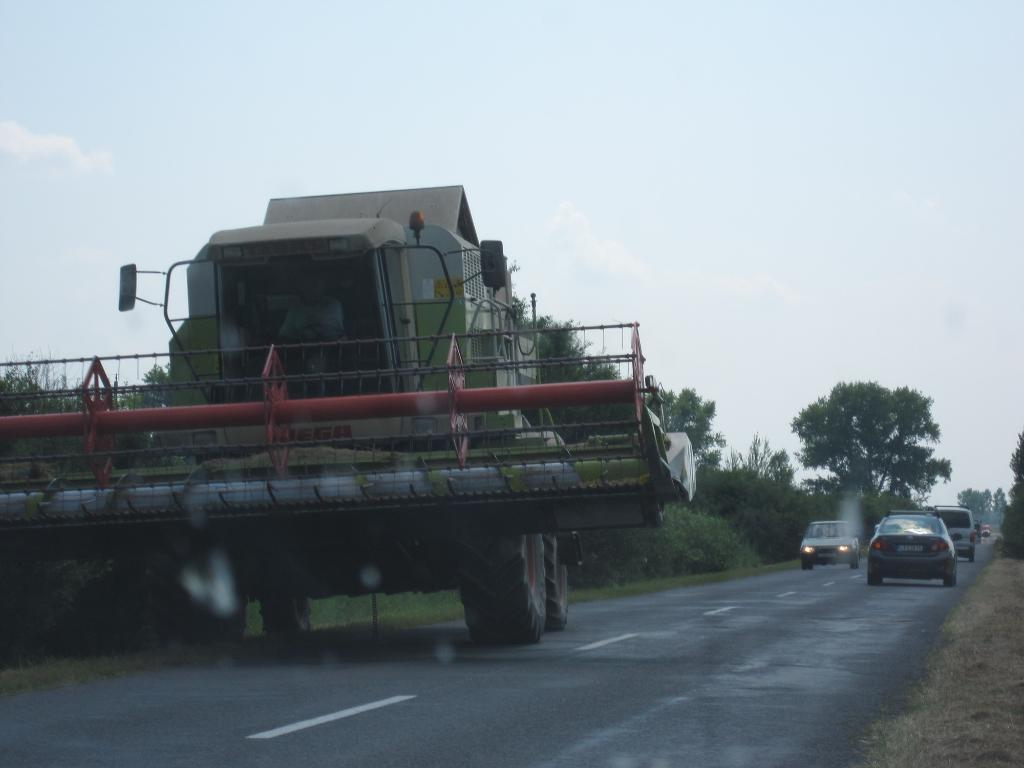What is the main feature of the image? There is a road in the image. What is happening on the road? There are cars on the road, and there is a person sitting on a truck. What can be seen at the side of the road? There are trees at the side of the road. What is visible above the road? The sky is visible in the image. How many fish are swimming in the river next to the road? There is no river or fish present in the image; it only features a road, cars, a person on a truck, trees, and the sky. 